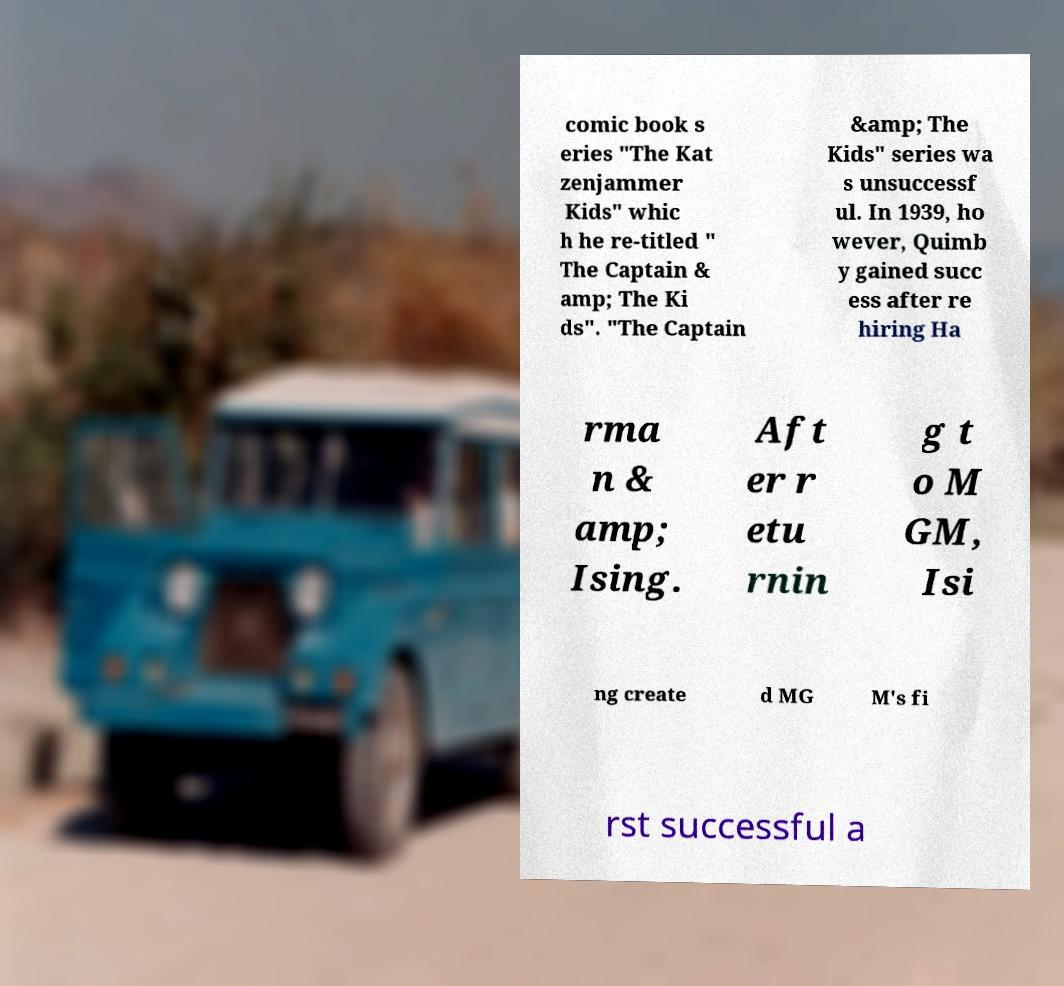Please identify and transcribe the text found in this image. comic book s eries "The Kat zenjammer Kids" whic h he re-titled " The Captain & amp; The Ki ds". "The Captain &amp; The Kids" series wa s unsuccessf ul. In 1939, ho wever, Quimb y gained succ ess after re hiring Ha rma n & amp; Ising. Aft er r etu rnin g t o M GM, Isi ng create d MG M's fi rst successful a 